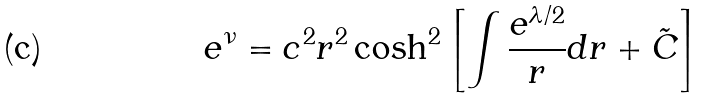<formula> <loc_0><loc_0><loc_500><loc_500>e ^ { \nu } = c ^ { 2 } r ^ { 2 } \cosh ^ { 2 } { \left [ \int { \frac { e ^ { \lambda / 2 } } { r } d r } + \tilde { C } \right ] }</formula> 